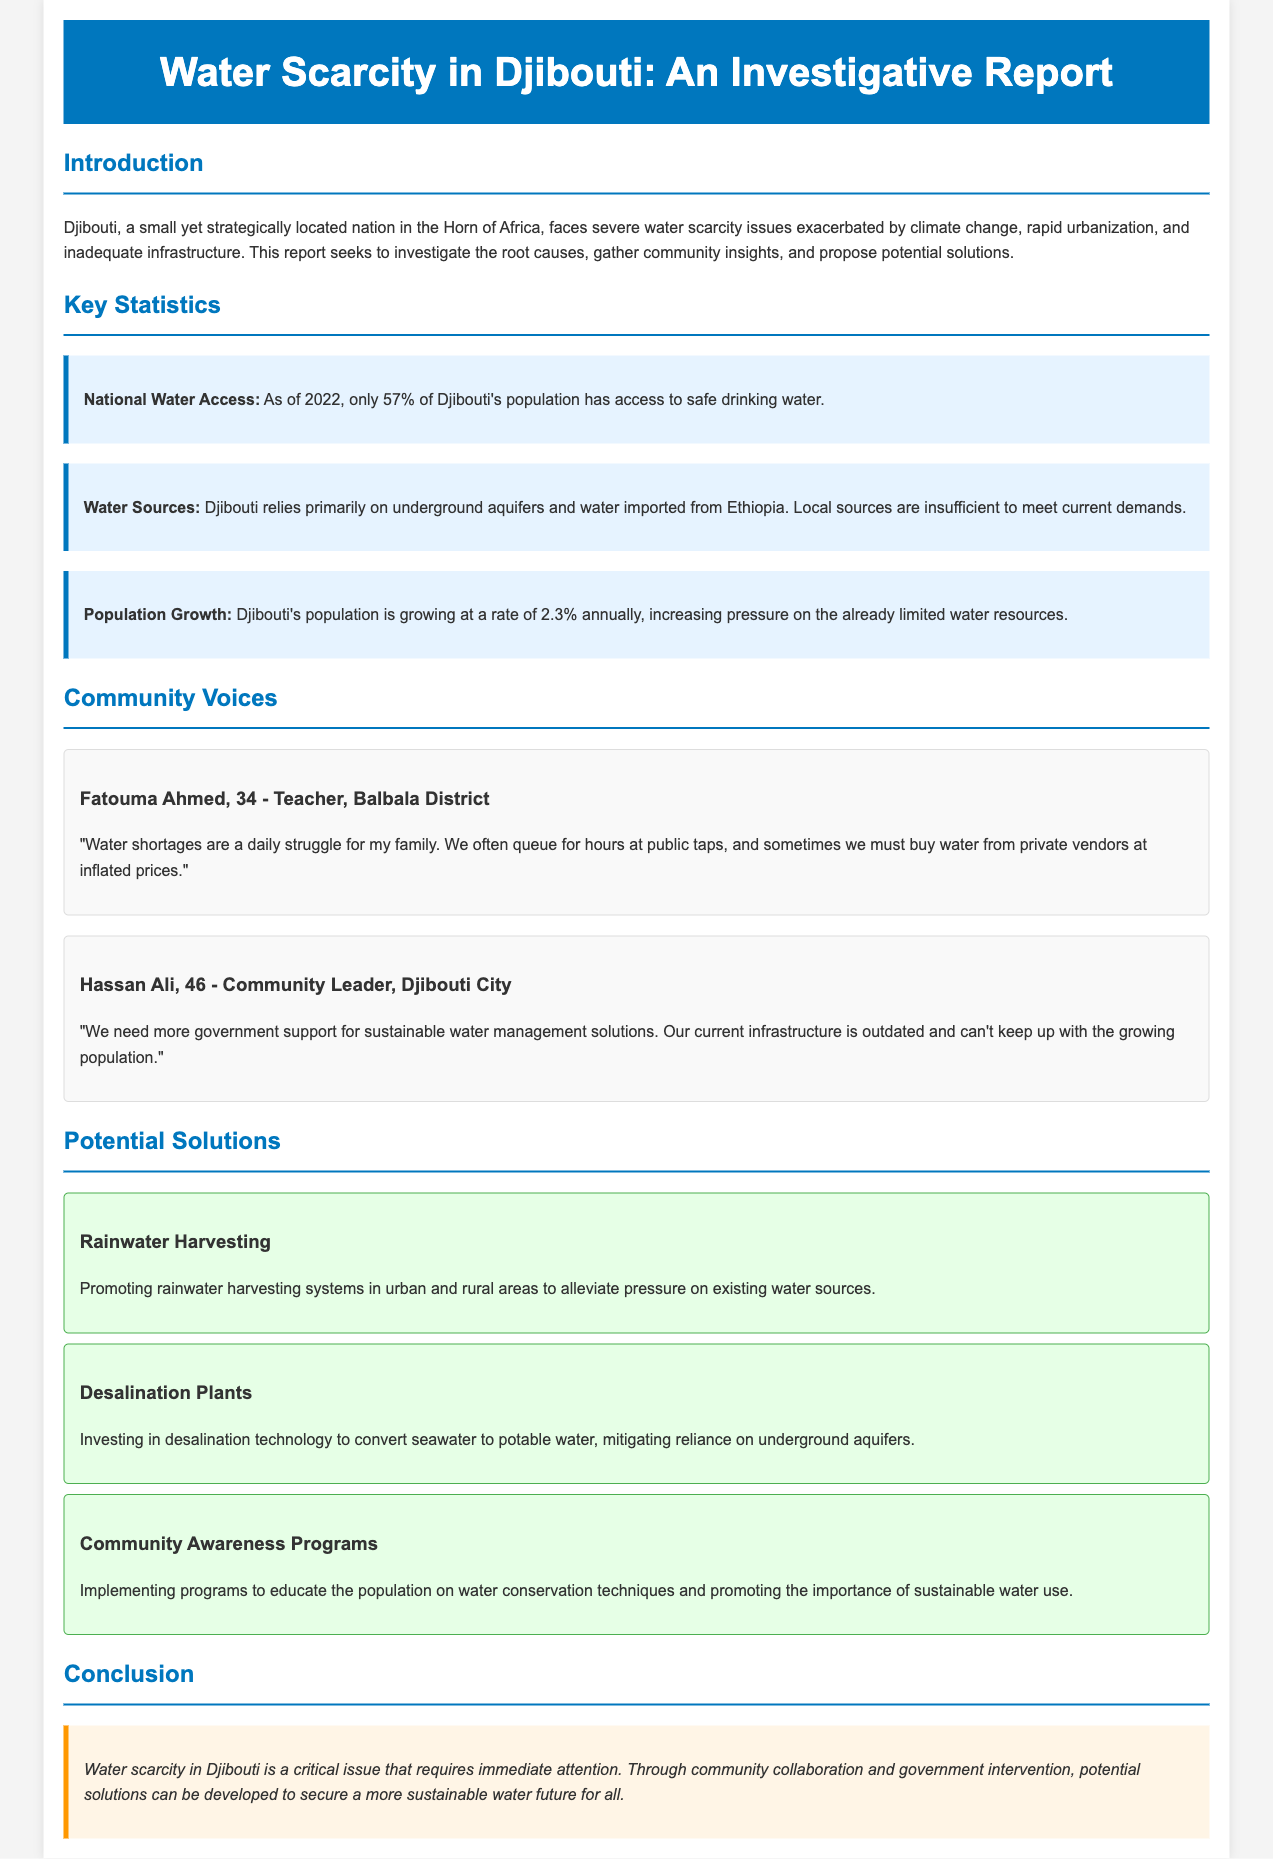What percentage of the population has access to safe drinking water? The document states that as of 2022, only 57% of Djibouti's population has access to safe drinking water.
Answer: 57% What is the population growth rate in Djibouti? The report indicates that Djibouti's population is growing at a rate of 2.3% annually.
Answer: 2.3% Who mentioned that water shortages are a daily struggle? The interview with Fatouma Ahmed reveals her struggles with water shortages.
Answer: Fatouma Ahmed What potential solution involves converting seawater to potable water? The document mentions investing in desalination technology as a solution to water scarcity.
Answer: Desalination Plants What community problem is noted in the report that affects daily life? The report highlights that residents often queue for hours at public taps.
Answer: Water shortages 